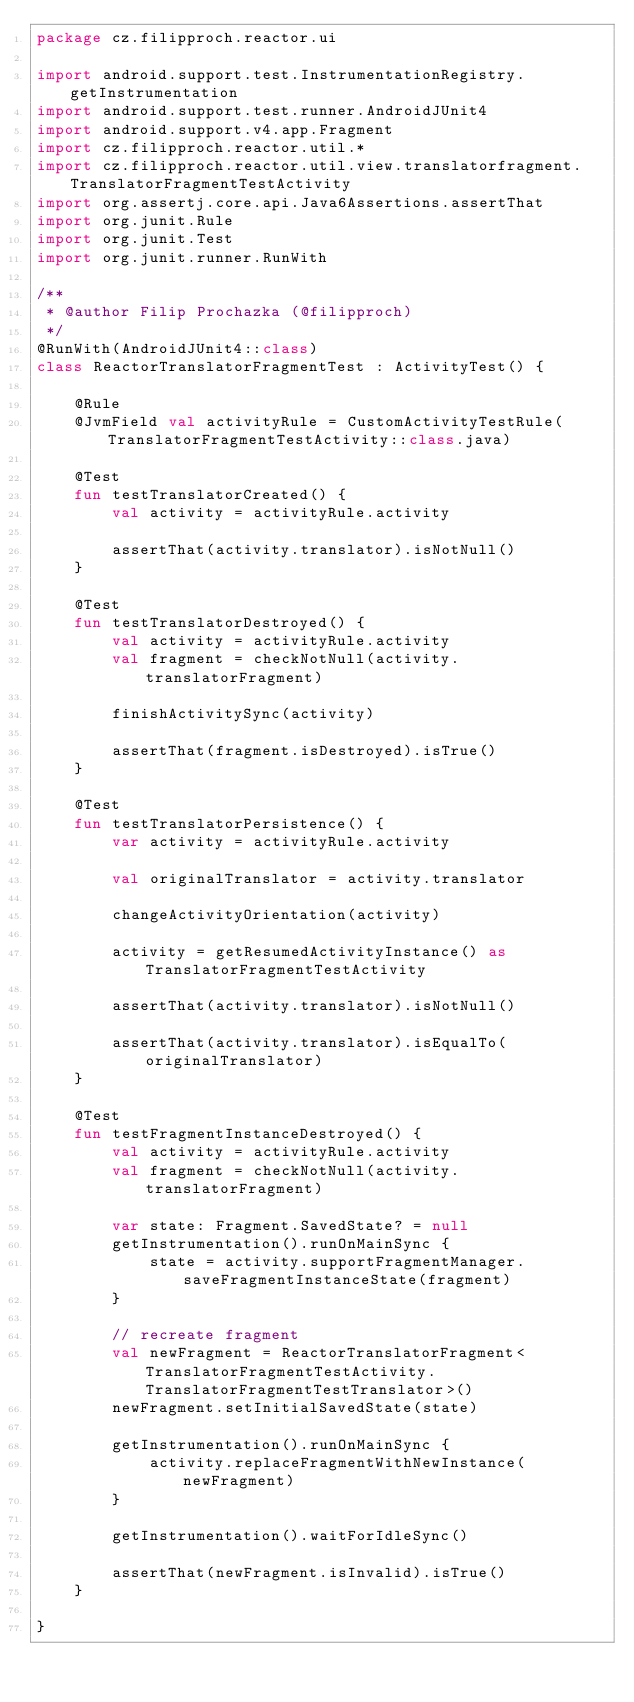<code> <loc_0><loc_0><loc_500><loc_500><_Kotlin_>package cz.filipproch.reactor.ui

import android.support.test.InstrumentationRegistry.getInstrumentation
import android.support.test.runner.AndroidJUnit4
import android.support.v4.app.Fragment
import cz.filipproch.reactor.util.*
import cz.filipproch.reactor.util.view.translatorfragment.TranslatorFragmentTestActivity
import org.assertj.core.api.Java6Assertions.assertThat
import org.junit.Rule
import org.junit.Test
import org.junit.runner.RunWith

/**
 * @author Filip Prochazka (@filipproch)
 */
@RunWith(AndroidJUnit4::class)
class ReactorTranslatorFragmentTest : ActivityTest() {

    @Rule
    @JvmField val activityRule = CustomActivityTestRule(TranslatorFragmentTestActivity::class.java)

    @Test
    fun testTranslatorCreated() {
        val activity = activityRule.activity

        assertThat(activity.translator).isNotNull()
    }

    @Test
    fun testTranslatorDestroyed() {
        val activity = activityRule.activity
        val fragment = checkNotNull(activity.translatorFragment)

        finishActivitySync(activity)

        assertThat(fragment.isDestroyed).isTrue()
    }

    @Test
    fun testTranslatorPersistence() {
        var activity = activityRule.activity

        val originalTranslator = activity.translator

        changeActivityOrientation(activity)

        activity = getResumedActivityInstance() as TranslatorFragmentTestActivity

        assertThat(activity.translator).isNotNull()

        assertThat(activity.translator).isEqualTo(originalTranslator)
    }

    @Test
    fun testFragmentInstanceDestroyed() {
        val activity = activityRule.activity
        val fragment = checkNotNull(activity.translatorFragment)

        var state: Fragment.SavedState? = null
        getInstrumentation().runOnMainSync {
            state = activity.supportFragmentManager.saveFragmentInstanceState(fragment)
        }

        // recreate fragment
        val newFragment = ReactorTranslatorFragment<TranslatorFragmentTestActivity.TranslatorFragmentTestTranslator>()
        newFragment.setInitialSavedState(state)

        getInstrumentation().runOnMainSync {
            activity.replaceFragmentWithNewInstance(newFragment)
        }

        getInstrumentation().waitForIdleSync()

        assertThat(newFragment.isInvalid).isTrue()
    }

}</code> 